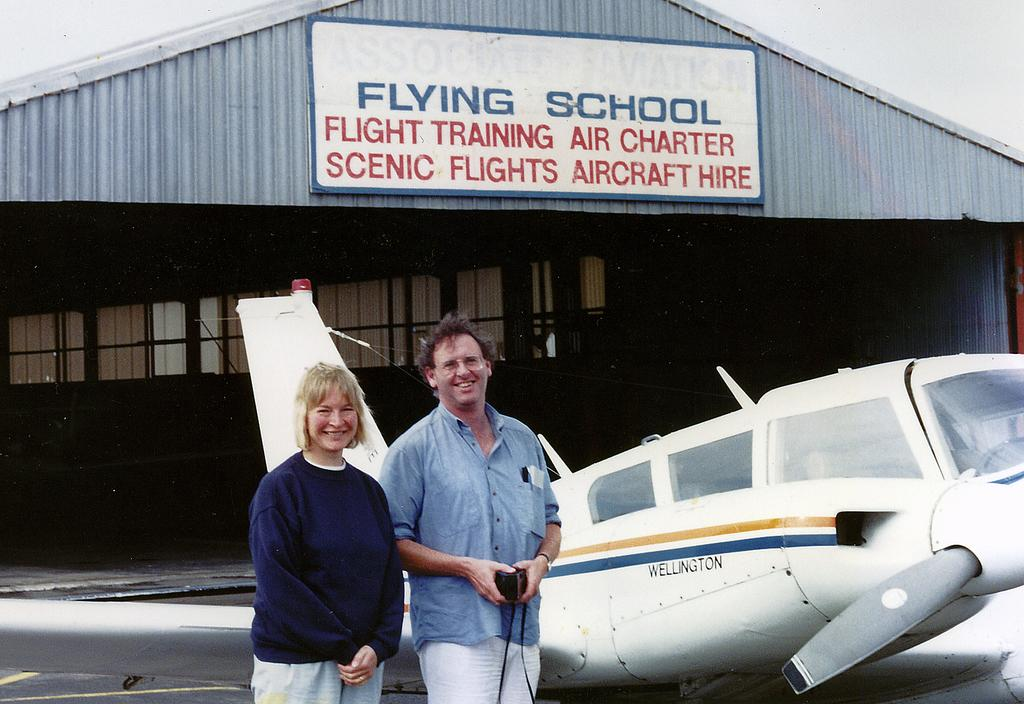How many people are in the image? There are two persons in the image. What are the persons doing in the image? The persons are standing near an aircraft. What can be seen in the background of the image? There is a shelter in the background of the image. What is written on the shelter? There is written text on the shelter. What is visible in the sky in the image? The sky is visible in the image. Can you see a net being used for amusement purposes in the image? There is no net or amusement activity present in the image. What type of shelf is visible in the image? There is no shelf present in the image. 